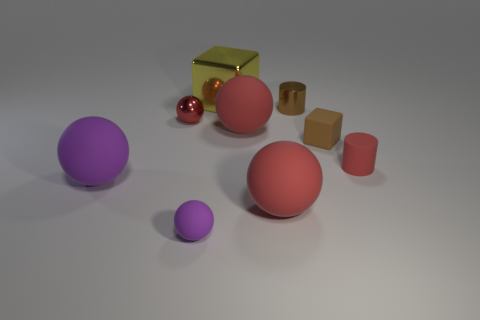Does the ball on the left side of the small red metal sphere have the same size as the metallic ball that is behind the small block?
Provide a succinct answer. No. There is a metal object on the left side of the metallic block; what color is it?
Offer a terse response. Red. Are there fewer spheres that are to the left of the tiny block than small rubber blocks?
Offer a very short reply. No. Do the small purple ball and the small red cylinder have the same material?
Provide a succinct answer. Yes. There is a red thing that is the same shape as the tiny brown metallic object; what is its size?
Offer a very short reply. Small. What number of things are either big rubber things that are to the left of the big yellow thing or metal things that are on the left side of the brown matte block?
Ensure brevity in your answer.  4. Are there fewer cylinders than big brown metallic blocks?
Keep it short and to the point. No. Does the brown block have the same size as the matte object that is behind the tiny brown matte object?
Provide a succinct answer. No. What number of shiny things are either big cubes or small blocks?
Make the answer very short. 1. Are there more tiny purple objects than large balls?
Give a very brief answer. No. 